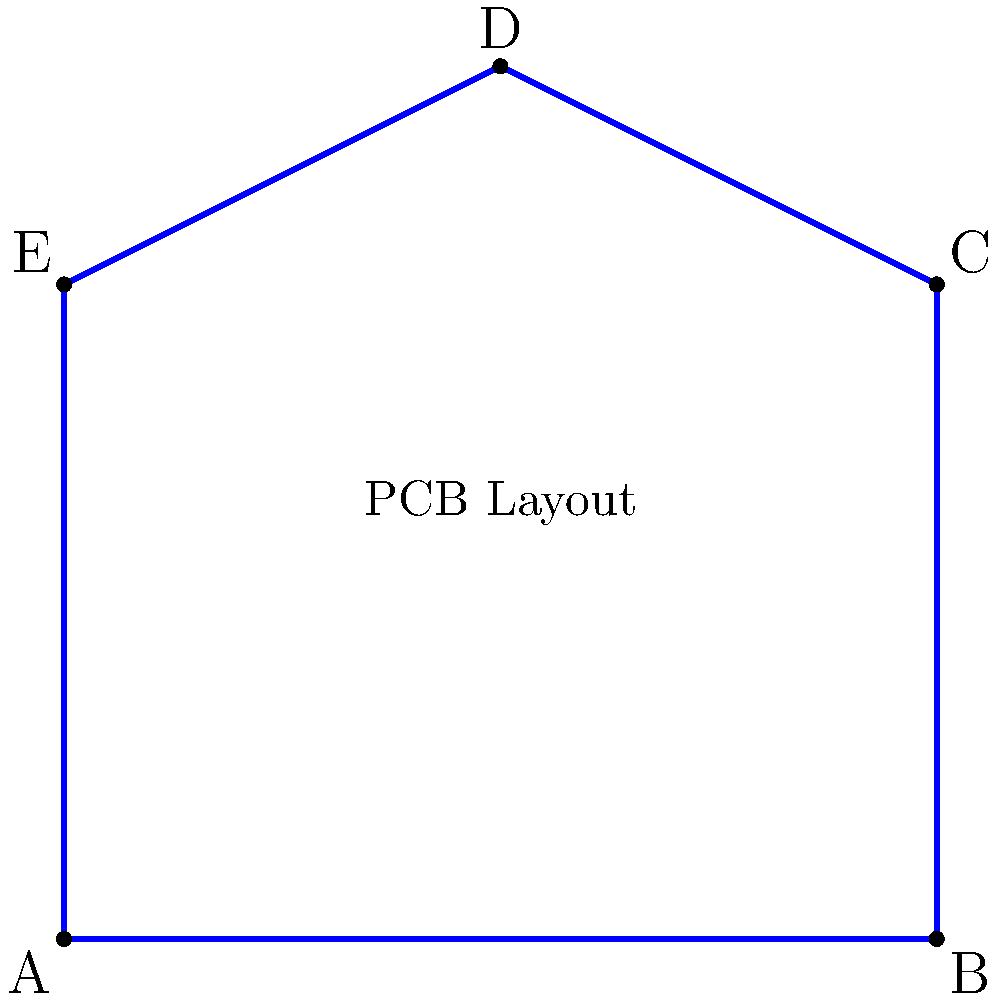In designing a PCB layout for a next-generation communication device, you need to determine the most efficient polygon shape to minimize signal interference. Given the pentagon ABCDE representing a potential PCB layout, calculate the interior angle sum of this polygon. How does this compare to other regular polygons, and what implications does this have for signal interference in PCB design? To answer this question, let's follow these steps:

1. Calculate the interior angle sum of the pentagon:
   The formula for the interior angle sum of a polygon with $n$ sides is:
   $S = (n-2) \times 180°$
   For a pentagon, $n = 5$, so:
   $S = (5-2) \times 180° = 3 \times 180° = 540°$

2. Compare to other regular polygons:
   - Triangle: $S = (3-2) \times 180° = 180°$
   - Square: $S = (4-2) \times 180° = 360°$
   - Hexagon: $S = (6-2) \times 180° = 720°$

3. Implications for signal interference:
   - More sides (larger interior angle sum) generally means a shape closer to a circle.
   - Circular shapes are often preferred in PCB design for components like antennas or ground planes, as they provide uniform signal distribution and minimize edge effects.
   - However, more complex shapes (more sides) can be harder to manufacture and may increase production costs.
   - The pentagon represents a balance between the simplicity of a square and the signal performance benefits of more circular shapes.

4. Considerations for PCB design:
   - The pentagon allows for more flexibility in component placement compared to a triangle or square.
   - It provides better signal distribution than a square but is easier to manufacture than a hexagon or octagon.
   - The 108° interior angles (540° / 5) of a regular pentagon are less sharp than those of a square (90°), potentially reducing signal reflections at corners.

In conclusion, while a circular shape would be ideal for minimizing signal interference, the pentagon offers a good compromise between performance and manufacturability in PCB design for next-generation communication devices.
Answer: 540°; balanced compromise between signal performance and manufacturability 